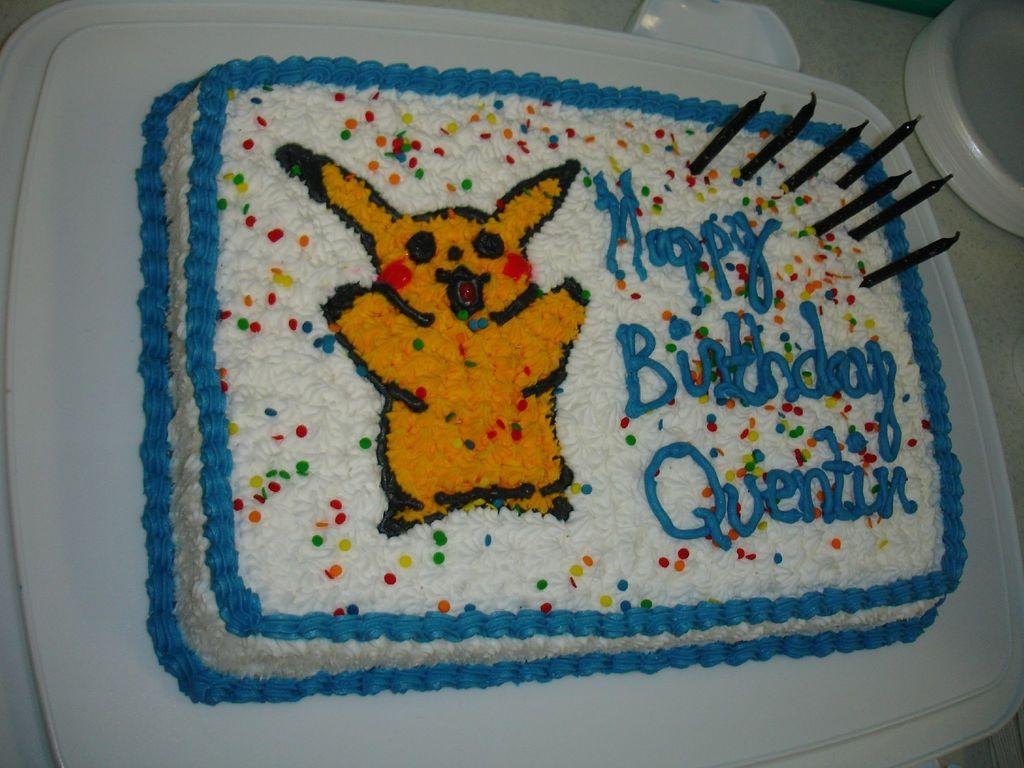What is the main subject of the image? The main subject of the image is a cake with candles. Where is the cake located in the image? The cake is placed on a table. What else can be seen on the table in the image? There are plates visible at the top right side of the image. What type of brass instrument is being played in the image? There is no brass instrument present in the image; it features a cake with candles on a table. What type of weather can be seen in the image? The image does not depict any weather conditions; it focuses on a cake with candles on a table. 